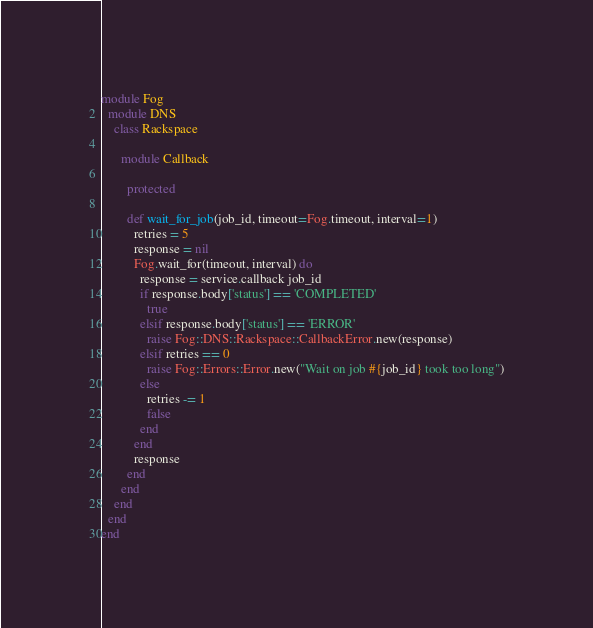Convert code to text. <code><loc_0><loc_0><loc_500><loc_500><_Ruby_>module Fog
  module DNS
    class Rackspace

      module Callback

        protected

        def wait_for_job(job_id, timeout=Fog.timeout, interval=1)
          retries = 5
          response = nil
          Fog.wait_for(timeout, interval) do
            response = service.callback job_id
            if response.body['status'] == 'COMPLETED'
              true
            elsif response.body['status'] == 'ERROR'
              raise Fog::DNS::Rackspace::CallbackError.new(response)
            elsif retries == 0
              raise Fog::Errors::Error.new("Wait on job #{job_id} took too long")
            else
              retries -= 1
              false
            end
          end
          response
        end
      end
    end
  end
end
</code> 